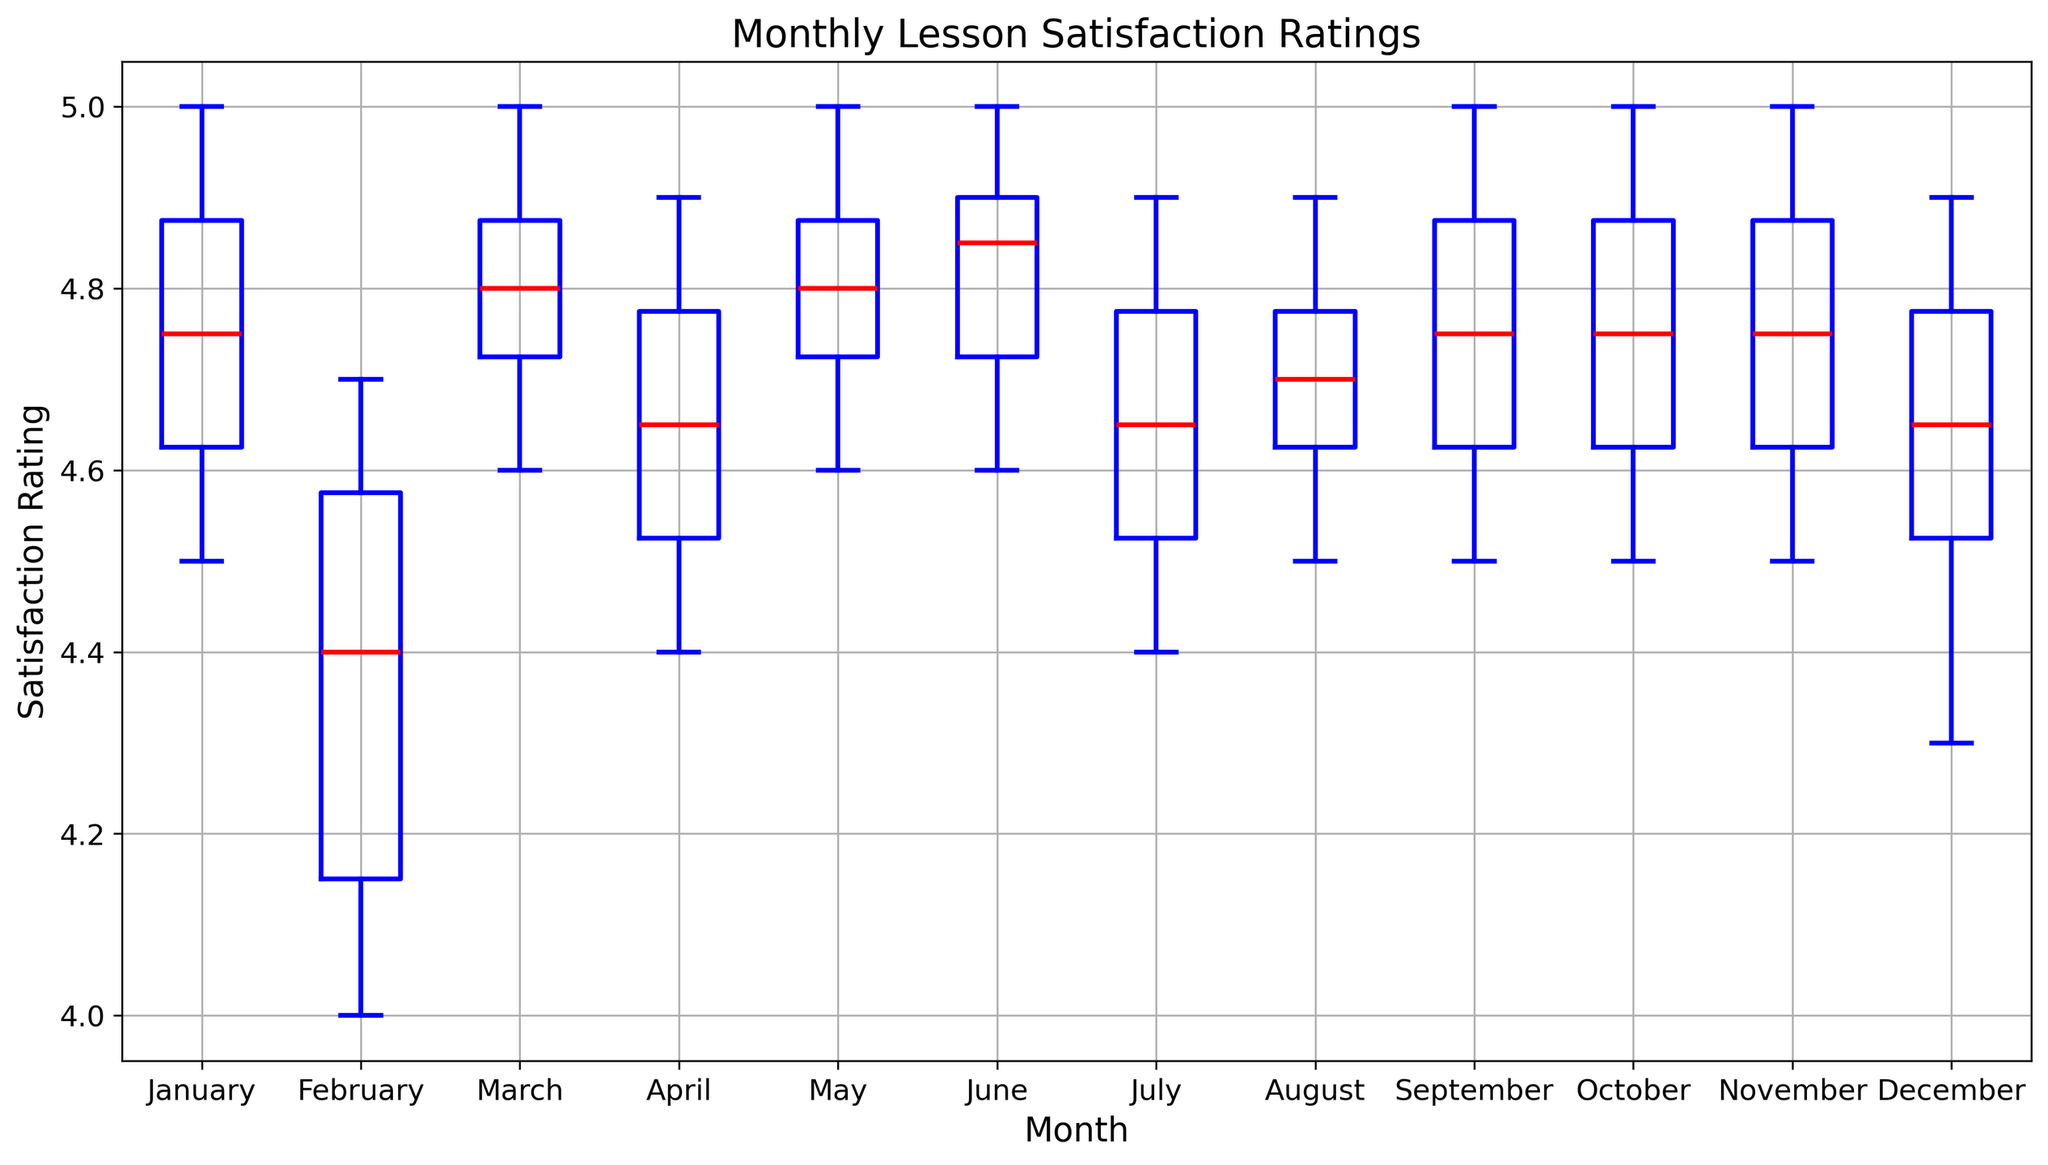Which month had the highest median lesson satisfaction rating? The median is represented by the red line in each month's box in the box plot. The highest red line belongs to November.
Answer: November Which month had the lowest median lesson satisfaction rating? The median is represented by the red line in each month's box. The lowest red line belongs to December.
Answer: December What is the interquartile range (IQR) for February? The IQR is the range between the first quartile (lower edge of the box) and the third quartile (upper edge of the box). For February, the IQR is from 4.1 to 4.6. So, the IQR is 4.6 - 4.1 = 0.5.
Answer: 0.5 During which month is the range of lesson satisfaction ratings the widest? The range is the difference between the highest and lowest data points (whiskers). The widest range is observed in December, from 4.3 to 4.9.
Answer: December Is there any month where the lesson satisfaction rating exceeds 5.0? The plot displays the outliers and the maximum within the whiskers, none of which exceed 5.0.
Answer: No Which months have at least one outlier in the lesson satisfaction ratings? Outliers are marked by orange circles. Reviewing the plot, no months display any orange circles indicating patient zero.
Answer: None Are there any months where the median lesson satisfaction rating is exactly 4.9? The median is marked by a red line inside each box. Months like July, September, and November have their median lines precisely at 4.9.
Answer: July, September, November How does the lesson satisfaction rating in July compare to that in October? Compare the median, IQR, and whiskers. Both have a similar median (around 4.7) and IQR, but July has a slightly wider overall range (4.4 to 4.9) compared to October (4.5 to 5.0).
Answer: July has a wider range Which month has the smallest interquartile range (IQR)? IQR is the range between the first and third quartiles. For July, it's particularly narrow, from around 4.6 to 4.8.
Answer: July 